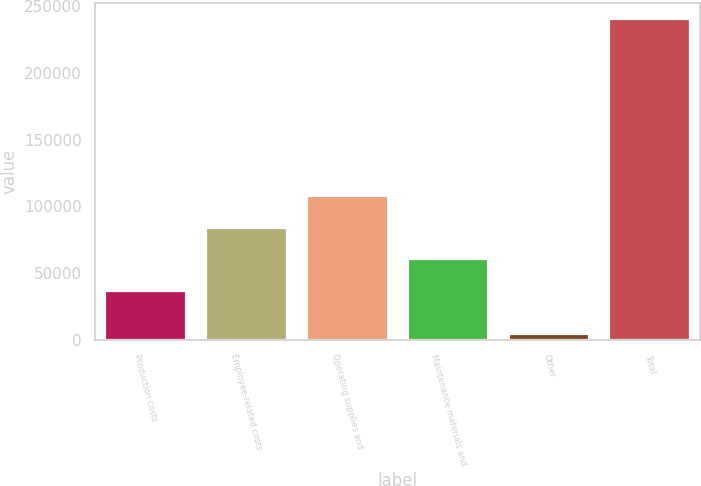Convert chart to OTSL. <chart><loc_0><loc_0><loc_500><loc_500><bar_chart><fcel>Production costs<fcel>Employee-related costs<fcel>Operating supplies and<fcel>Maintenance materials and<fcel>Other<fcel>Total<nl><fcel>36753<fcel>83980.8<fcel>107595<fcel>60366.9<fcel>4471<fcel>240610<nl></chart> 